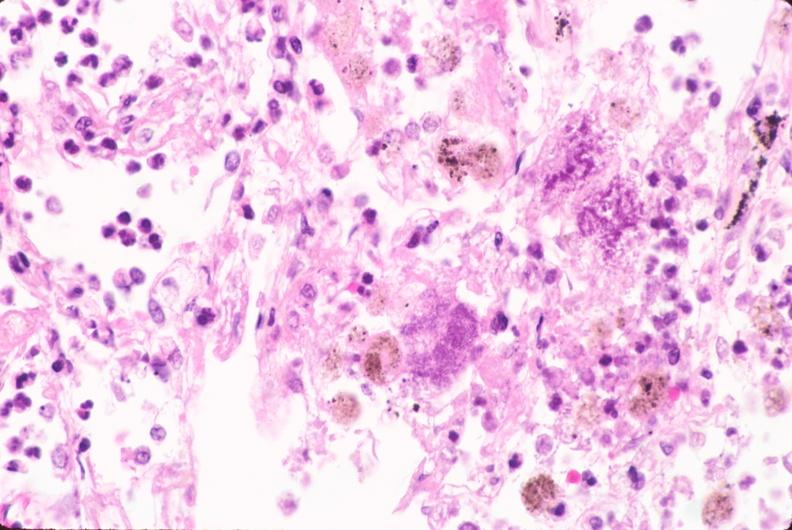what does this image show?
Answer the question using a single word or phrase. Lung 